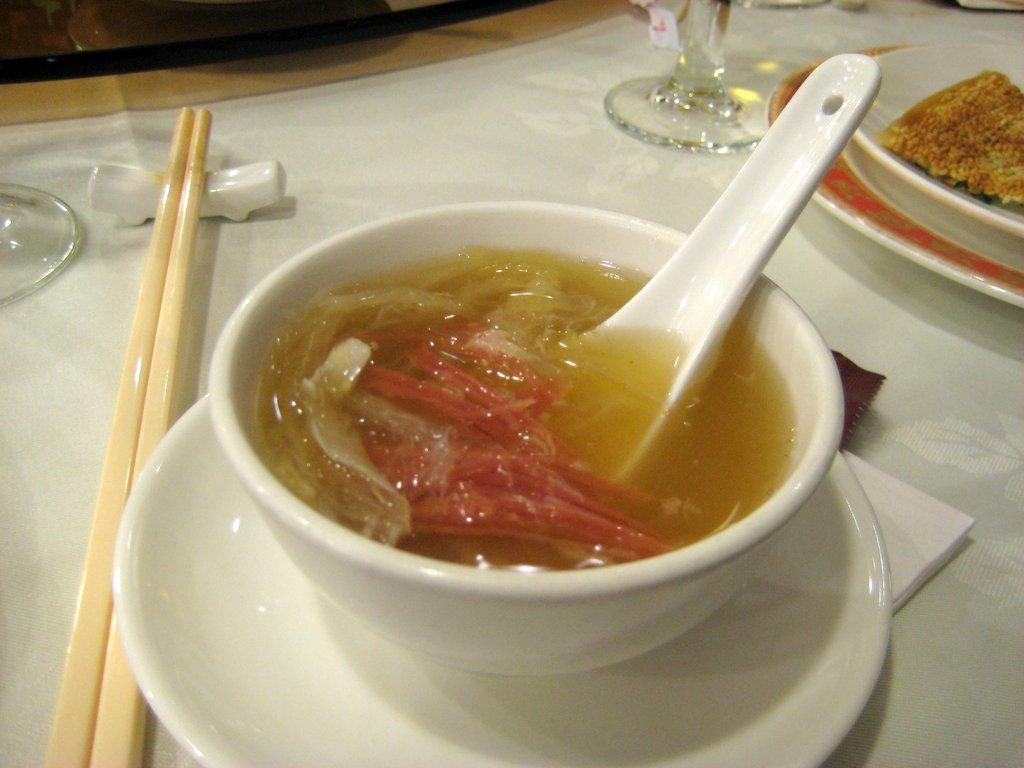Can you describe this image briefly? In this picture there is crockery on the table. In the center there is a bowl placed on a plate and in it there is soup. To the above right corner there is a plate and in it there is food. On the table there are glasses, chopsticks and tissues. 